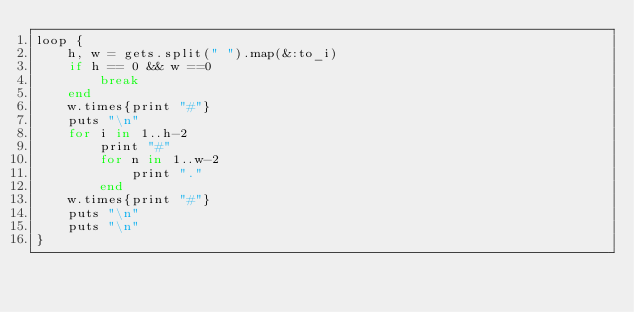<code> <loc_0><loc_0><loc_500><loc_500><_Ruby_>loop {
    h, w = gets.split(" ").map(&:to_i)
    if h == 0 && w ==0
        break
    end
    w.times{print "#"}
    puts "\n"
    for i in 1..h-2
        print "#"
        for n in 1..w-2
            print "."
        end
    w.times{print "#"}
    puts "\n"
    puts "\n"
}</code> 